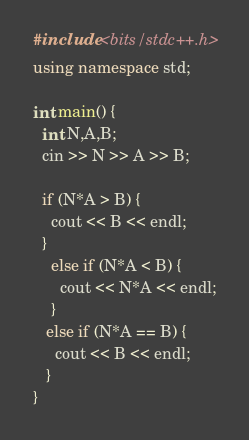Convert code to text. <code><loc_0><loc_0><loc_500><loc_500><_C++_>#include <bits/stdc++.h>
using namespace std;

int main() {
  int N,A,B;
  cin >> N >> A >> B;
  
  if (N*A > B) {
    cout << B << endl;
  }
    else if (N*A < B) {
      cout << N*A << endl;
    }
   else if (N*A == B) {
     cout << B << endl;
   }
}</code> 